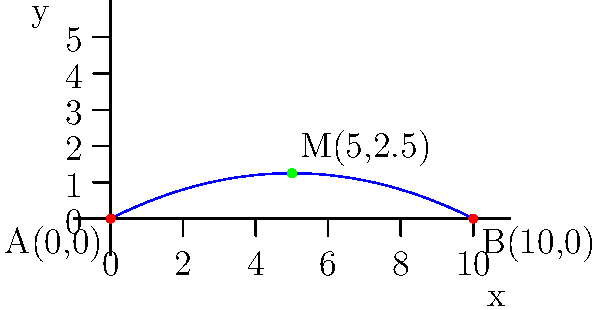During your floor routine, you perform a tumbling pass that follows a parabolic trajectory. The starting point of your pass is at coordinates (0,0), and you land at coordinates (10,0). Find the coordinates of the midpoint of your trajectory, which represents the highest point of your tumbling pass. Let's approach this step-by-step:

1) The trajectory is represented by a parabola that starts at (0,0) and ends at (10,0).

2) To find the midpoint, we need to calculate the average of the x-coordinates and the average of the y-coordinates of the endpoints.

3) For the x-coordinate of the midpoint:
   $x_{midpoint} = \frac{x_1 + x_2}{2} = \frac{0 + 10}{2} = 5$

4) For the y-coordinate, we need to find the height of the parabola at x = 5.

5) The general equation of a parabola is $y = ax^2 + bx + c$. Since it passes through (0,0) and (10,0), we know that $c = 0$ and $10a + b = 0$.

6) The vertex of the parabola is at the midpoint, so the axis of symmetry is $x = 5$. This means $b = -10a$.

7) Substituting these into the general equation:
   $y = ax^2 - 10ax$
   $y = ax(x - 10)$

8) To find $a$, we can use the fact that the parabola reaches its maximum at x = 5:
   $\frac{dy}{dx} = a(2x - 10) = 0$ when $x = 5$
   $a(10 - 10) = 0$, which is true for any $a$

9) We can choose $a = -0.05$ to make the parabola reach a reasonable height.

10) Therefore, the equation of the parabola is:
    $y = -0.05x^2 + 0.5x$

11) At $x = 5$, the height is:
    $y = -0.05(5^2) + 0.5(5) = -1.25 + 2.5 = 2.5$

Thus, the coordinates of the midpoint are (5, 2.5).
Answer: (5, 2.5) 